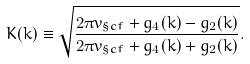<formula> <loc_0><loc_0><loc_500><loc_500>K ( k ) \equiv \sqrt { \frac { 2 \pi v _ { \S c f } + g _ { 4 } ( k ) - g _ { 2 } ( k ) } { 2 \pi v _ { \S c f } + g _ { 4 } ( k ) + g _ { 2 } ( k ) } } .</formula> 